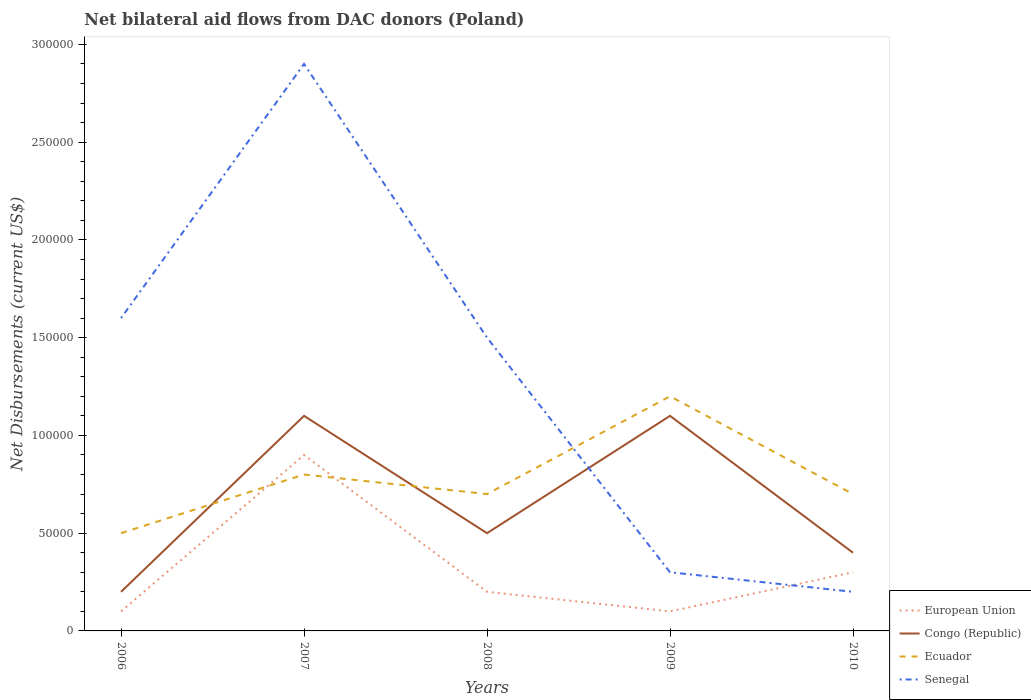Does the line corresponding to Ecuador intersect with the line corresponding to Senegal?
Ensure brevity in your answer.  Yes. Is the number of lines equal to the number of legend labels?
Keep it short and to the point. Yes. Across all years, what is the maximum net bilateral aid flows in Ecuador?
Give a very brief answer. 5.00e+04. What is the total net bilateral aid flows in Senegal in the graph?
Your answer should be compact. 1.30e+05. What is the difference between the highest and the second highest net bilateral aid flows in Senegal?
Ensure brevity in your answer.  2.70e+05. What is the difference between the highest and the lowest net bilateral aid flows in European Union?
Offer a very short reply. 1. Is the net bilateral aid flows in Congo (Republic) strictly greater than the net bilateral aid flows in Senegal over the years?
Make the answer very short. No. How many years are there in the graph?
Ensure brevity in your answer.  5. Does the graph contain any zero values?
Your response must be concise. No. Does the graph contain grids?
Give a very brief answer. No. How many legend labels are there?
Offer a very short reply. 4. What is the title of the graph?
Provide a succinct answer. Net bilateral aid flows from DAC donors (Poland). Does "Antigua and Barbuda" appear as one of the legend labels in the graph?
Your answer should be compact. No. What is the label or title of the X-axis?
Your response must be concise. Years. What is the label or title of the Y-axis?
Make the answer very short. Net Disbursements (current US$). What is the Net Disbursements (current US$) in Senegal in 2006?
Provide a succinct answer. 1.60e+05. What is the Net Disbursements (current US$) of European Union in 2007?
Make the answer very short. 9.00e+04. What is the Net Disbursements (current US$) of Congo (Republic) in 2007?
Provide a succinct answer. 1.10e+05. What is the Net Disbursements (current US$) of Ecuador in 2007?
Ensure brevity in your answer.  8.00e+04. What is the Net Disbursements (current US$) of Senegal in 2007?
Keep it short and to the point. 2.90e+05. What is the Net Disbursements (current US$) of European Union in 2008?
Provide a succinct answer. 2.00e+04. What is the Net Disbursements (current US$) of Congo (Republic) in 2008?
Offer a terse response. 5.00e+04. What is the Net Disbursements (current US$) of Congo (Republic) in 2009?
Provide a short and direct response. 1.10e+05. What is the Net Disbursements (current US$) of Senegal in 2009?
Your answer should be compact. 3.00e+04. What is the Net Disbursements (current US$) of European Union in 2010?
Provide a short and direct response. 3.00e+04. What is the Net Disbursements (current US$) of Congo (Republic) in 2010?
Provide a short and direct response. 4.00e+04. What is the Net Disbursements (current US$) in Ecuador in 2010?
Your response must be concise. 7.00e+04. What is the Net Disbursements (current US$) in Senegal in 2010?
Ensure brevity in your answer.  2.00e+04. Across all years, what is the maximum Net Disbursements (current US$) in European Union?
Your response must be concise. 9.00e+04. Across all years, what is the maximum Net Disbursements (current US$) of Senegal?
Your answer should be compact. 2.90e+05. Across all years, what is the minimum Net Disbursements (current US$) of Congo (Republic)?
Your answer should be very brief. 2.00e+04. Across all years, what is the minimum Net Disbursements (current US$) of Senegal?
Give a very brief answer. 2.00e+04. What is the total Net Disbursements (current US$) of European Union in the graph?
Your answer should be compact. 1.60e+05. What is the total Net Disbursements (current US$) of Ecuador in the graph?
Offer a very short reply. 3.90e+05. What is the total Net Disbursements (current US$) of Senegal in the graph?
Provide a short and direct response. 6.50e+05. What is the difference between the Net Disbursements (current US$) in Senegal in 2006 and that in 2007?
Provide a succinct answer. -1.30e+05. What is the difference between the Net Disbursements (current US$) in European Union in 2006 and that in 2008?
Provide a succinct answer. -10000. What is the difference between the Net Disbursements (current US$) of Congo (Republic) in 2006 and that in 2008?
Ensure brevity in your answer.  -3.00e+04. What is the difference between the Net Disbursements (current US$) of Ecuador in 2006 and that in 2008?
Keep it short and to the point. -2.00e+04. What is the difference between the Net Disbursements (current US$) in European Union in 2006 and that in 2009?
Your answer should be very brief. 0. What is the difference between the Net Disbursements (current US$) of Congo (Republic) in 2006 and that in 2009?
Your response must be concise. -9.00e+04. What is the difference between the Net Disbursements (current US$) of European Union in 2006 and that in 2010?
Provide a short and direct response. -2.00e+04. What is the difference between the Net Disbursements (current US$) of Congo (Republic) in 2007 and that in 2008?
Ensure brevity in your answer.  6.00e+04. What is the difference between the Net Disbursements (current US$) in Ecuador in 2007 and that in 2008?
Keep it short and to the point. 10000. What is the difference between the Net Disbursements (current US$) in Senegal in 2007 and that in 2008?
Ensure brevity in your answer.  1.40e+05. What is the difference between the Net Disbursements (current US$) of Ecuador in 2007 and that in 2009?
Provide a succinct answer. -4.00e+04. What is the difference between the Net Disbursements (current US$) of European Union in 2007 and that in 2010?
Offer a very short reply. 6.00e+04. What is the difference between the Net Disbursements (current US$) of Senegal in 2007 and that in 2010?
Provide a short and direct response. 2.70e+05. What is the difference between the Net Disbursements (current US$) in Congo (Republic) in 2008 and that in 2009?
Offer a very short reply. -6.00e+04. What is the difference between the Net Disbursements (current US$) in Ecuador in 2008 and that in 2009?
Ensure brevity in your answer.  -5.00e+04. What is the difference between the Net Disbursements (current US$) in Senegal in 2008 and that in 2009?
Your response must be concise. 1.20e+05. What is the difference between the Net Disbursements (current US$) of Congo (Republic) in 2008 and that in 2010?
Your response must be concise. 10000. What is the difference between the Net Disbursements (current US$) in Ecuador in 2008 and that in 2010?
Offer a terse response. 0. What is the difference between the Net Disbursements (current US$) in Senegal in 2008 and that in 2010?
Give a very brief answer. 1.30e+05. What is the difference between the Net Disbursements (current US$) in Congo (Republic) in 2009 and that in 2010?
Offer a very short reply. 7.00e+04. What is the difference between the Net Disbursements (current US$) of Ecuador in 2009 and that in 2010?
Your answer should be very brief. 5.00e+04. What is the difference between the Net Disbursements (current US$) of European Union in 2006 and the Net Disbursements (current US$) of Senegal in 2007?
Offer a terse response. -2.80e+05. What is the difference between the Net Disbursements (current US$) of Congo (Republic) in 2006 and the Net Disbursements (current US$) of Ecuador in 2007?
Keep it short and to the point. -6.00e+04. What is the difference between the Net Disbursements (current US$) of Ecuador in 2006 and the Net Disbursements (current US$) of Senegal in 2008?
Make the answer very short. -1.00e+05. What is the difference between the Net Disbursements (current US$) in European Union in 2006 and the Net Disbursements (current US$) in Congo (Republic) in 2009?
Make the answer very short. -1.00e+05. What is the difference between the Net Disbursements (current US$) in European Union in 2006 and the Net Disbursements (current US$) in Ecuador in 2009?
Provide a succinct answer. -1.10e+05. What is the difference between the Net Disbursements (current US$) of Congo (Republic) in 2006 and the Net Disbursements (current US$) of Senegal in 2009?
Provide a succinct answer. -10000. What is the difference between the Net Disbursements (current US$) of Ecuador in 2006 and the Net Disbursements (current US$) of Senegal in 2009?
Your answer should be very brief. 2.00e+04. What is the difference between the Net Disbursements (current US$) of European Union in 2007 and the Net Disbursements (current US$) of Congo (Republic) in 2008?
Provide a succinct answer. 4.00e+04. What is the difference between the Net Disbursements (current US$) of European Union in 2007 and the Net Disbursements (current US$) of Ecuador in 2008?
Make the answer very short. 2.00e+04. What is the difference between the Net Disbursements (current US$) of European Union in 2007 and the Net Disbursements (current US$) of Senegal in 2008?
Your answer should be compact. -6.00e+04. What is the difference between the Net Disbursements (current US$) in Congo (Republic) in 2007 and the Net Disbursements (current US$) in Ecuador in 2008?
Make the answer very short. 4.00e+04. What is the difference between the Net Disbursements (current US$) of European Union in 2007 and the Net Disbursements (current US$) of Congo (Republic) in 2009?
Keep it short and to the point. -2.00e+04. What is the difference between the Net Disbursements (current US$) in Congo (Republic) in 2007 and the Net Disbursements (current US$) in Senegal in 2009?
Your answer should be compact. 8.00e+04. What is the difference between the Net Disbursements (current US$) in Ecuador in 2007 and the Net Disbursements (current US$) in Senegal in 2009?
Offer a terse response. 5.00e+04. What is the difference between the Net Disbursements (current US$) of European Union in 2007 and the Net Disbursements (current US$) of Senegal in 2010?
Offer a terse response. 7.00e+04. What is the difference between the Net Disbursements (current US$) of Ecuador in 2007 and the Net Disbursements (current US$) of Senegal in 2010?
Keep it short and to the point. 6.00e+04. What is the difference between the Net Disbursements (current US$) of European Union in 2008 and the Net Disbursements (current US$) of Congo (Republic) in 2009?
Provide a short and direct response. -9.00e+04. What is the difference between the Net Disbursements (current US$) of Congo (Republic) in 2008 and the Net Disbursements (current US$) of Ecuador in 2009?
Make the answer very short. -7.00e+04. What is the difference between the Net Disbursements (current US$) of Congo (Republic) in 2008 and the Net Disbursements (current US$) of Senegal in 2009?
Give a very brief answer. 2.00e+04. What is the difference between the Net Disbursements (current US$) in European Union in 2008 and the Net Disbursements (current US$) in Ecuador in 2010?
Give a very brief answer. -5.00e+04. What is the difference between the Net Disbursements (current US$) of Congo (Republic) in 2008 and the Net Disbursements (current US$) of Senegal in 2010?
Give a very brief answer. 3.00e+04. What is the difference between the Net Disbursements (current US$) of European Union in 2009 and the Net Disbursements (current US$) of Congo (Republic) in 2010?
Your answer should be very brief. -3.00e+04. What is the difference between the Net Disbursements (current US$) in Congo (Republic) in 2009 and the Net Disbursements (current US$) in Ecuador in 2010?
Ensure brevity in your answer.  4.00e+04. What is the difference between the Net Disbursements (current US$) of Congo (Republic) in 2009 and the Net Disbursements (current US$) of Senegal in 2010?
Offer a very short reply. 9.00e+04. What is the average Net Disbursements (current US$) of European Union per year?
Your response must be concise. 3.20e+04. What is the average Net Disbursements (current US$) in Congo (Republic) per year?
Provide a short and direct response. 6.60e+04. What is the average Net Disbursements (current US$) of Ecuador per year?
Your answer should be very brief. 7.80e+04. What is the average Net Disbursements (current US$) of Senegal per year?
Your answer should be very brief. 1.30e+05. In the year 2006, what is the difference between the Net Disbursements (current US$) of European Union and Net Disbursements (current US$) of Congo (Republic)?
Ensure brevity in your answer.  -10000. In the year 2006, what is the difference between the Net Disbursements (current US$) of European Union and Net Disbursements (current US$) of Ecuador?
Your answer should be compact. -4.00e+04. In the year 2006, what is the difference between the Net Disbursements (current US$) in European Union and Net Disbursements (current US$) in Senegal?
Ensure brevity in your answer.  -1.50e+05. In the year 2006, what is the difference between the Net Disbursements (current US$) of Congo (Republic) and Net Disbursements (current US$) of Senegal?
Make the answer very short. -1.40e+05. In the year 2006, what is the difference between the Net Disbursements (current US$) in Ecuador and Net Disbursements (current US$) in Senegal?
Your answer should be very brief. -1.10e+05. In the year 2007, what is the difference between the Net Disbursements (current US$) of European Union and Net Disbursements (current US$) of Ecuador?
Provide a succinct answer. 10000. In the year 2007, what is the difference between the Net Disbursements (current US$) in European Union and Net Disbursements (current US$) in Senegal?
Your answer should be very brief. -2.00e+05. In the year 2007, what is the difference between the Net Disbursements (current US$) in Congo (Republic) and Net Disbursements (current US$) in Ecuador?
Ensure brevity in your answer.  3.00e+04. In the year 2008, what is the difference between the Net Disbursements (current US$) in European Union and Net Disbursements (current US$) in Ecuador?
Offer a very short reply. -5.00e+04. In the year 2008, what is the difference between the Net Disbursements (current US$) in Congo (Republic) and Net Disbursements (current US$) in Senegal?
Offer a very short reply. -1.00e+05. In the year 2009, what is the difference between the Net Disbursements (current US$) of European Union and Net Disbursements (current US$) of Senegal?
Provide a succinct answer. -2.00e+04. In the year 2009, what is the difference between the Net Disbursements (current US$) of Congo (Republic) and Net Disbursements (current US$) of Ecuador?
Ensure brevity in your answer.  -10000. In the year 2010, what is the difference between the Net Disbursements (current US$) of European Union and Net Disbursements (current US$) of Ecuador?
Keep it short and to the point. -4.00e+04. In the year 2010, what is the difference between the Net Disbursements (current US$) of Congo (Republic) and Net Disbursements (current US$) of Senegal?
Provide a short and direct response. 2.00e+04. In the year 2010, what is the difference between the Net Disbursements (current US$) in Ecuador and Net Disbursements (current US$) in Senegal?
Provide a short and direct response. 5.00e+04. What is the ratio of the Net Disbursements (current US$) in Congo (Republic) in 2006 to that in 2007?
Offer a terse response. 0.18. What is the ratio of the Net Disbursements (current US$) of Senegal in 2006 to that in 2007?
Offer a very short reply. 0.55. What is the ratio of the Net Disbursements (current US$) of Congo (Republic) in 2006 to that in 2008?
Ensure brevity in your answer.  0.4. What is the ratio of the Net Disbursements (current US$) in Senegal in 2006 to that in 2008?
Your answer should be compact. 1.07. What is the ratio of the Net Disbursements (current US$) in Congo (Republic) in 2006 to that in 2009?
Provide a succinct answer. 0.18. What is the ratio of the Net Disbursements (current US$) of Ecuador in 2006 to that in 2009?
Offer a very short reply. 0.42. What is the ratio of the Net Disbursements (current US$) of Senegal in 2006 to that in 2009?
Give a very brief answer. 5.33. What is the ratio of the Net Disbursements (current US$) of European Union in 2006 to that in 2010?
Give a very brief answer. 0.33. What is the ratio of the Net Disbursements (current US$) of Ecuador in 2006 to that in 2010?
Make the answer very short. 0.71. What is the ratio of the Net Disbursements (current US$) of Senegal in 2007 to that in 2008?
Provide a succinct answer. 1.93. What is the ratio of the Net Disbursements (current US$) in Ecuador in 2007 to that in 2009?
Provide a short and direct response. 0.67. What is the ratio of the Net Disbursements (current US$) in Senegal in 2007 to that in 2009?
Give a very brief answer. 9.67. What is the ratio of the Net Disbursements (current US$) in European Union in 2007 to that in 2010?
Offer a terse response. 3. What is the ratio of the Net Disbursements (current US$) in Congo (Republic) in 2007 to that in 2010?
Provide a succinct answer. 2.75. What is the ratio of the Net Disbursements (current US$) in Senegal in 2007 to that in 2010?
Make the answer very short. 14.5. What is the ratio of the Net Disbursements (current US$) of Congo (Republic) in 2008 to that in 2009?
Offer a terse response. 0.45. What is the ratio of the Net Disbursements (current US$) in Ecuador in 2008 to that in 2009?
Keep it short and to the point. 0.58. What is the ratio of the Net Disbursements (current US$) in Senegal in 2008 to that in 2009?
Offer a very short reply. 5. What is the ratio of the Net Disbursements (current US$) of Senegal in 2008 to that in 2010?
Keep it short and to the point. 7.5. What is the ratio of the Net Disbursements (current US$) in European Union in 2009 to that in 2010?
Your answer should be compact. 0.33. What is the ratio of the Net Disbursements (current US$) of Congo (Republic) in 2009 to that in 2010?
Provide a succinct answer. 2.75. What is the ratio of the Net Disbursements (current US$) of Ecuador in 2009 to that in 2010?
Keep it short and to the point. 1.71. What is the difference between the highest and the second highest Net Disbursements (current US$) in European Union?
Offer a very short reply. 6.00e+04. What is the difference between the highest and the second highest Net Disbursements (current US$) of Congo (Republic)?
Your answer should be very brief. 0. What is the difference between the highest and the lowest Net Disbursements (current US$) in European Union?
Make the answer very short. 8.00e+04. What is the difference between the highest and the lowest Net Disbursements (current US$) of Ecuador?
Offer a terse response. 7.00e+04. What is the difference between the highest and the lowest Net Disbursements (current US$) of Senegal?
Your answer should be compact. 2.70e+05. 